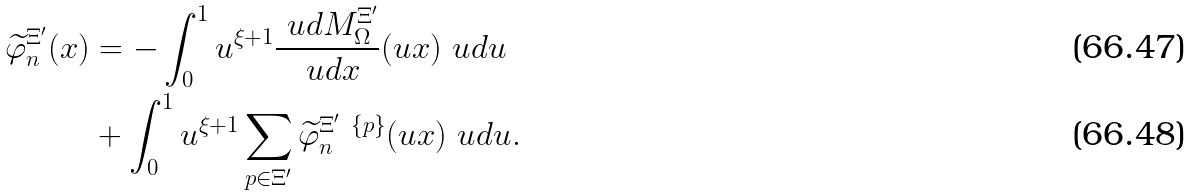Convert formula to latex. <formula><loc_0><loc_0><loc_500><loc_500>\widetilde { \varphi } _ { n } ^ { \Xi ^ { \prime } } ( x ) & = - \int _ { 0 } ^ { 1 } u ^ { \xi + 1 } \frac { \ u d M _ { \Omega } ^ { \Xi ^ { \prime } } } { \ u d x } ( u x ) \ u d u \\ & + \int _ { 0 } ^ { 1 } u ^ { \xi + 1 } \sum _ { p \in \Xi ^ { \prime } } \widetilde { \varphi } _ { n } ^ { \Xi ^ { \prime } \ \{ p \} } ( u x ) \ u d u .</formula> 